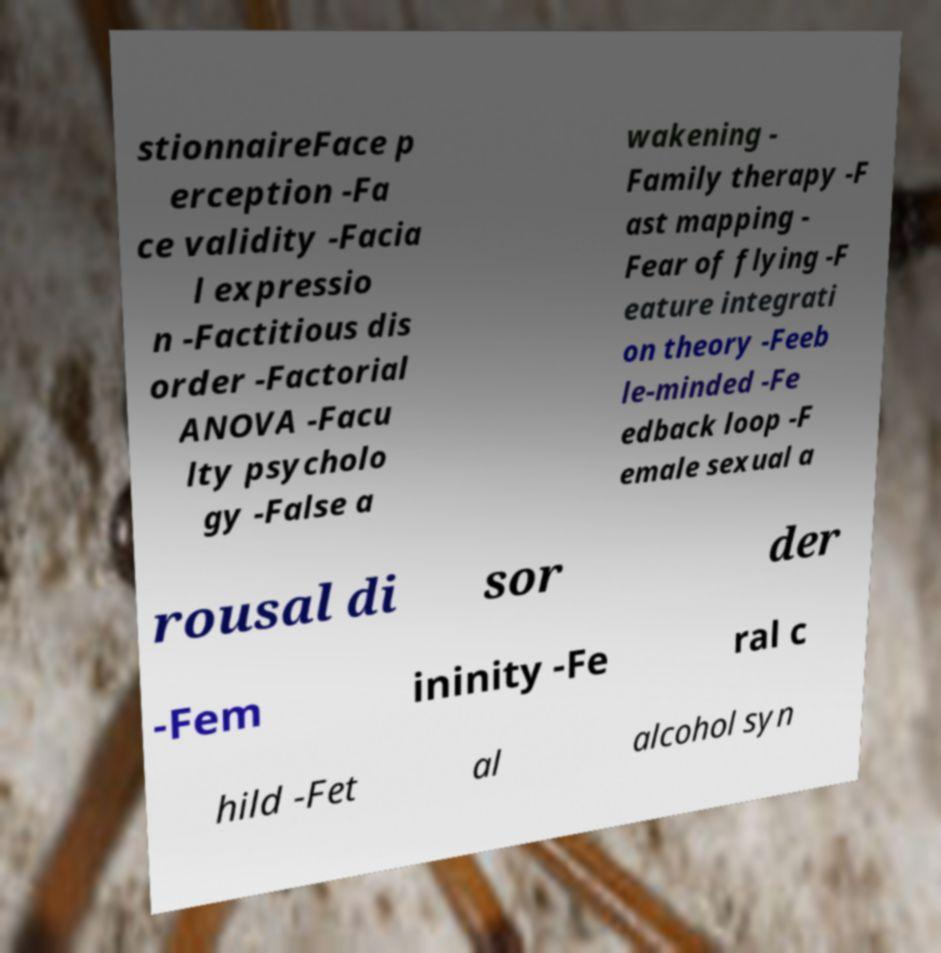Could you assist in decoding the text presented in this image and type it out clearly? stionnaireFace p erception -Fa ce validity -Facia l expressio n -Factitious dis order -Factorial ANOVA -Facu lty psycholo gy -False a wakening - Family therapy -F ast mapping - Fear of flying -F eature integrati on theory -Feeb le-minded -Fe edback loop -F emale sexual a rousal di sor der -Fem ininity -Fe ral c hild -Fet al alcohol syn 